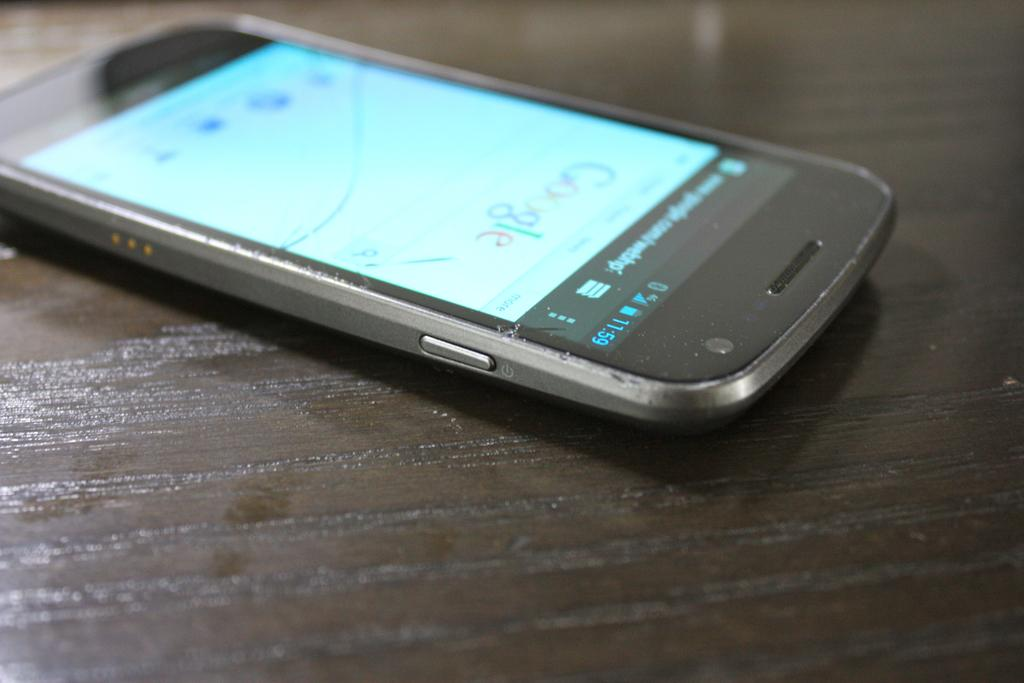<image>
Provide a brief description of the given image. Cellphone that has the Google website on the screen. 